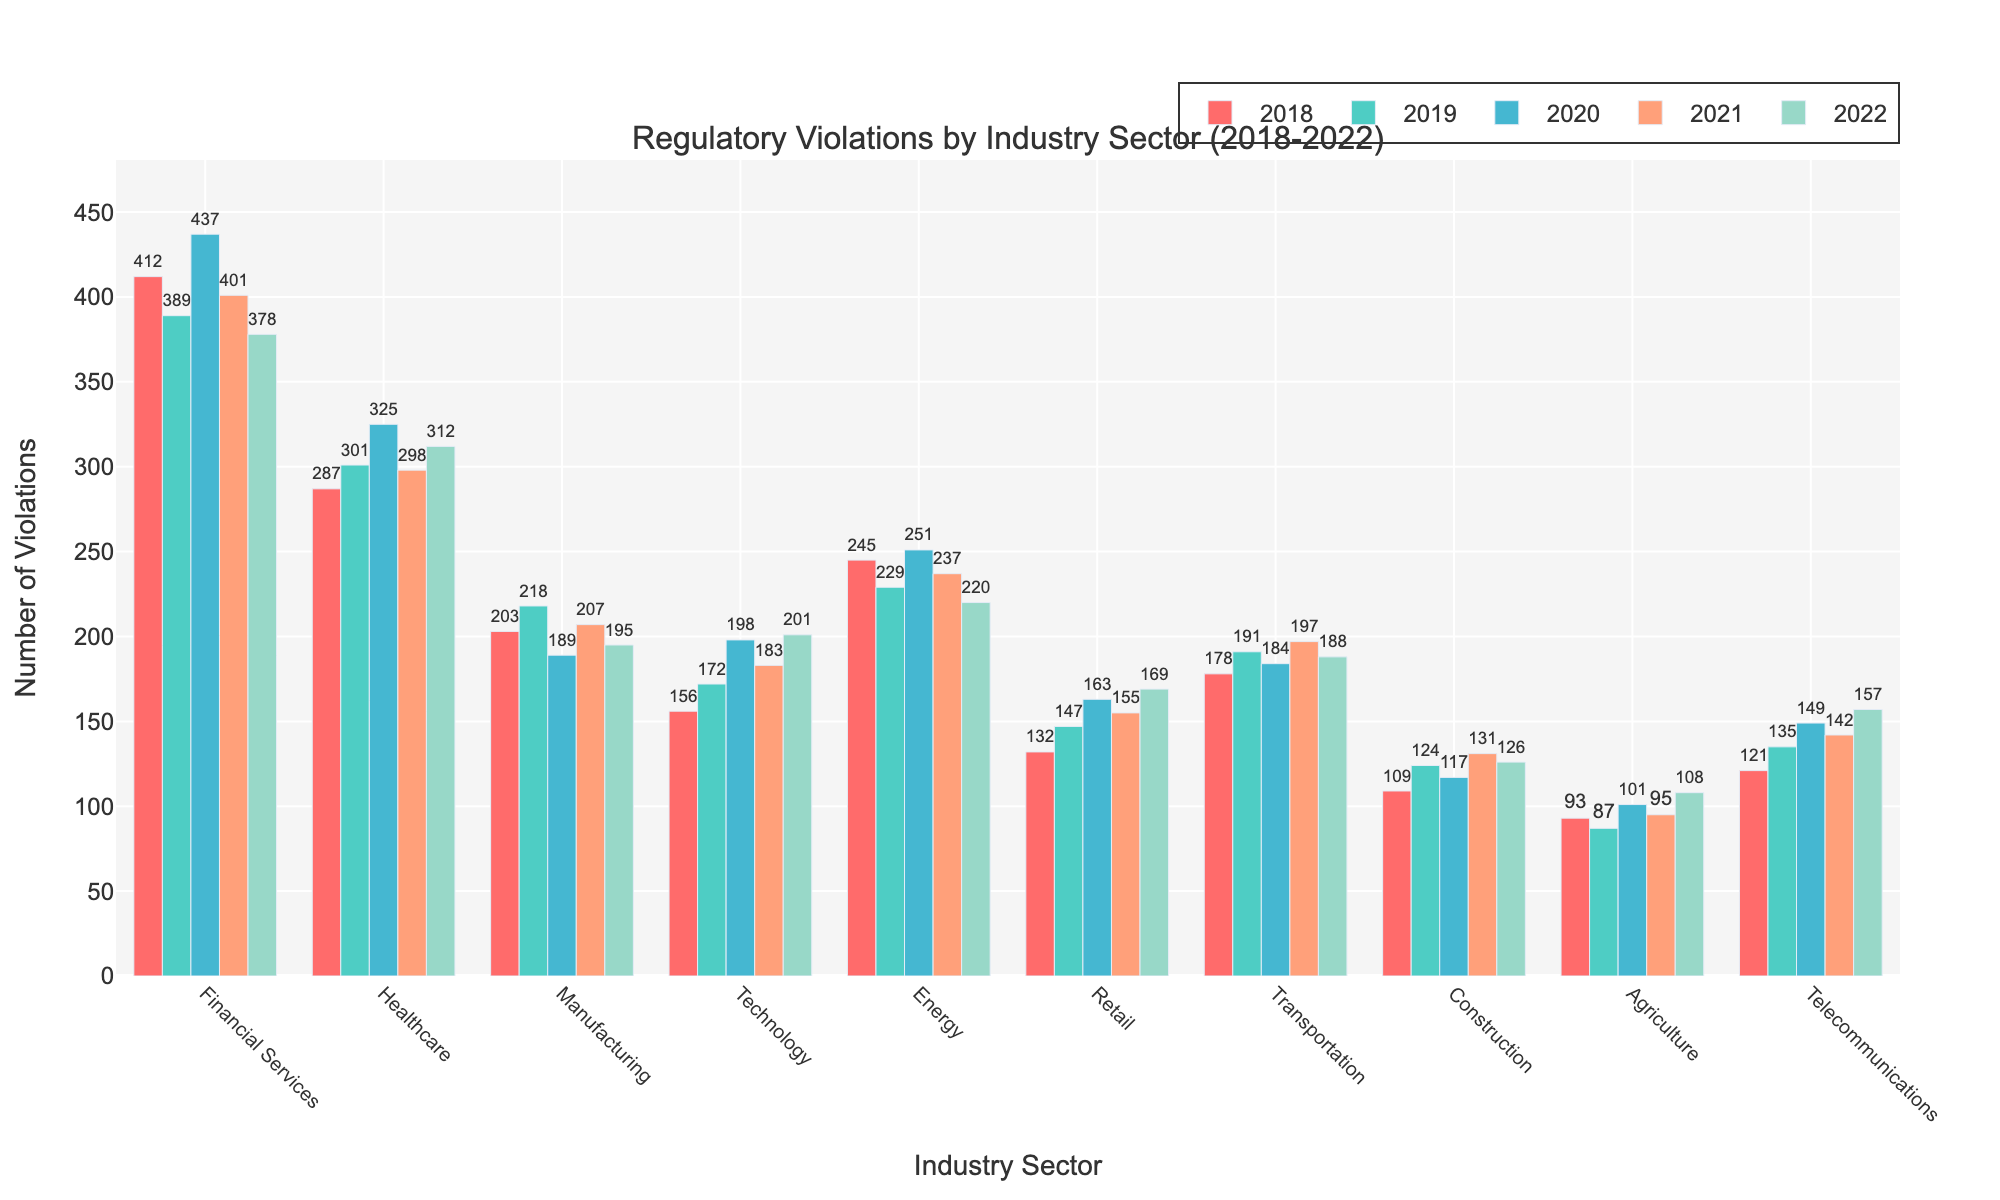What industry had the highest number of regulatory violations in 2020? By observing the height of the bars in 2020, we see that the Financial Services industry has the tallest bar.
Answer: Financial Services Which industry sector saw the greatest decrease in the number of violations from 2018 to 2022? Compare the heights of the bars for each industry between 2018 and 2022. Financial Services decreased from 412 to 378. Other decreases are smaller than this drop of 34 violations.
Answer: Financial Services How did the number of violations in the Healthcare sector change from 2019 to 2020? Look at the heights of the bars for Healthcare in 2019 and 2020. In 2019, there were 301 violations, and in 2020, there were 325 violations. Calculate the difference: 325 - 301 = 24.
Answer: Increased by 24 Which industry had a greater number of regulatory violations in 2022, Energy or Telecommunications? Compare the heights of the bars for Energy and Telecommunications in 2022. Telecommunications has a higher bar.
Answer: Telecommunications What is the total number of violations across all industries in 2018? Sum the heights of all bars in 2018: 412 (Financial Services) + 287 (Healthcare) + 203 (Manufacturing) + 156 (Technology) + 245 (Energy) + 132 (Retail) + 178 (Transportation) + 109 (Construction) + 93 (Agriculture) + 121 (Telecommunications) = 1936.
Answer: 1936 What is the average number of violations in the Manufacturing sector over the past 5 years? Sum the number of violations in Manufacturing for each year and then divide by 5: (203 + 218 + 189 + 207 + 195) / 5 = 202.4.
Answer: 202.4 Which year saw the highest number of violations in the Technology sector? Compare the heights of the Technology bars for each year and identify the tallest. In 2022, the bar is the tallest with 201 violations.
Answer: 2022 How many more violations did the Financial Services sector have compared to the Retail sector in 2018? Subtract the number of violations in Retail from Financial Services in 2018: 412 (Financial Services) - 132 (Retail) = 280.
Answer: 280 Which industry experienced the smallest change in the number of violations between 2018 and 2022? Calculate the differences between 2018 and 2022 for each industry and find the smallest change. Manufacturing changed by only 8 (203 in 2018 to 195 in 2022).
Answer: Manufacturing Is the number of violations in the Transportation sector in 2021 greater than that in the Construction sector in 2022? Compare the heights of the bars for Transportation in 2021 and Construction in 2022. The Transportation sector had 197, and Construction had 126, so yes, 197 is greater than 126.
Answer: Yes 